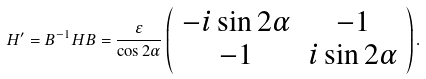<formula> <loc_0><loc_0><loc_500><loc_500>H ^ { \prime } = B ^ { - 1 } H B = \frac { \varepsilon } { \cos 2 \alpha } \left ( \begin{array} { c c } - i \sin 2 \alpha & - 1 \\ - 1 & i \sin 2 \alpha \end{array} \right ) .</formula> 